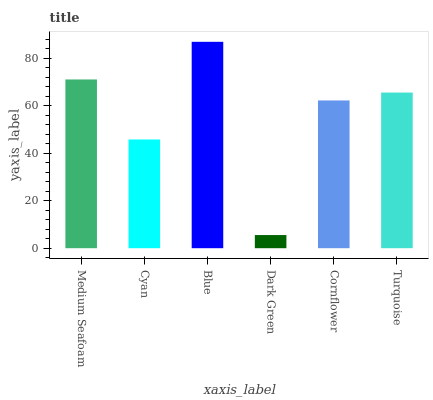Is Dark Green the minimum?
Answer yes or no. Yes. Is Blue the maximum?
Answer yes or no. Yes. Is Cyan the minimum?
Answer yes or no. No. Is Cyan the maximum?
Answer yes or no. No. Is Medium Seafoam greater than Cyan?
Answer yes or no. Yes. Is Cyan less than Medium Seafoam?
Answer yes or no. Yes. Is Cyan greater than Medium Seafoam?
Answer yes or no. No. Is Medium Seafoam less than Cyan?
Answer yes or no. No. Is Turquoise the high median?
Answer yes or no. Yes. Is Cornflower the low median?
Answer yes or no. Yes. Is Cyan the high median?
Answer yes or no. No. Is Turquoise the low median?
Answer yes or no. No. 